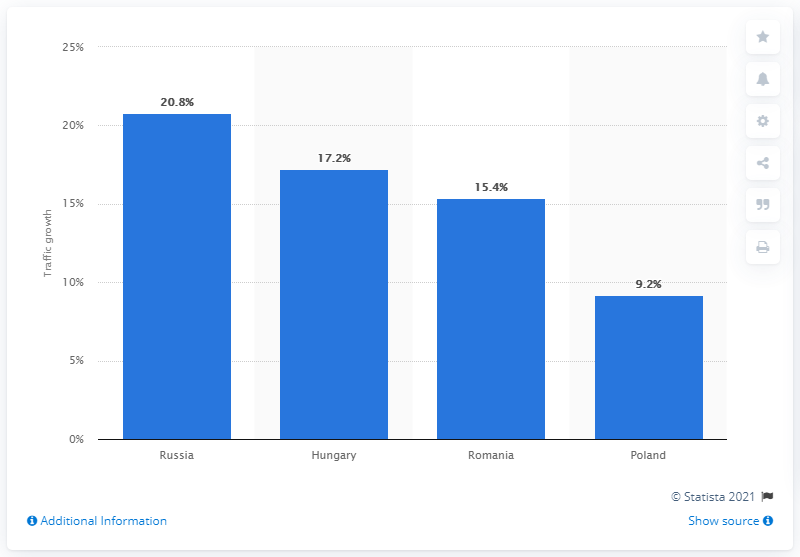Highlight a few significant elements in this photo. The country with the highest traffic growth was Russia. 